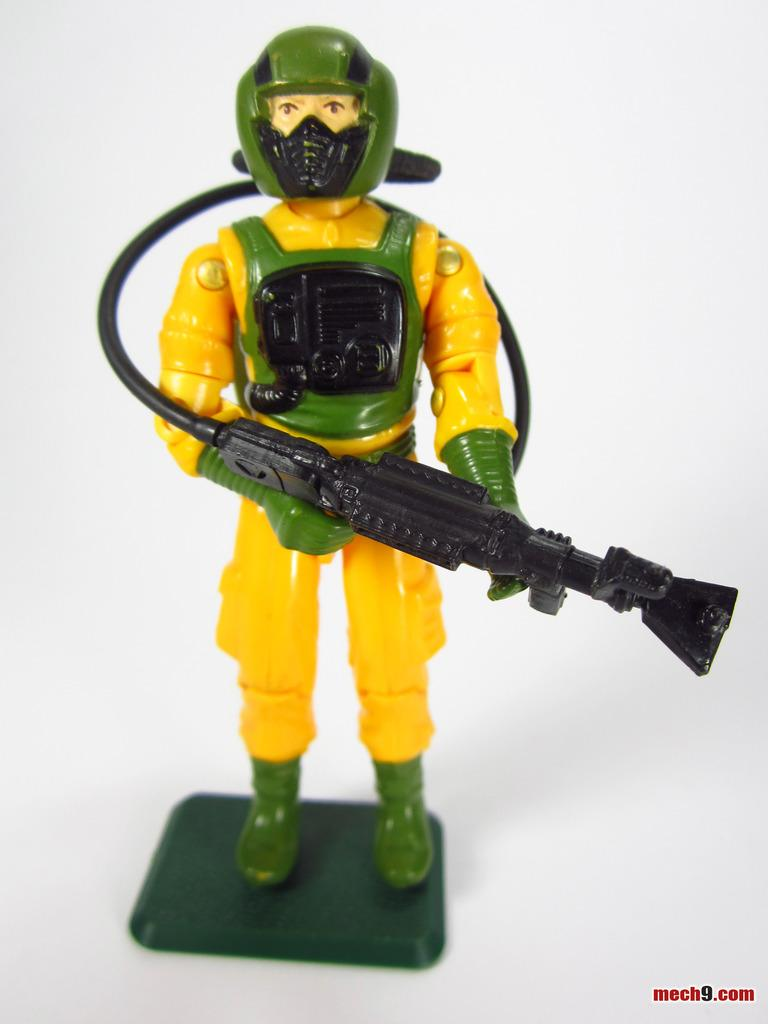What object can be seen in the picture? There is a toy in the picture. What is the toy holding? The toy is holding a plastic gun. Where is the toy placed? The toy is placed on a table. Is there any additional information about the image? Yes, there is a watermark in the bottom right corner of the image. What type of basket is visible in the picture? There is no basket present in the image. Can you tell me where the toy was purchased from in the image? There is no information about where the toy was purchased from in the image. 